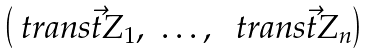<formula> <loc_0><loc_0><loc_500><loc_500>\begin{pmatrix} \ t r a n s { \vec { t } { Z } _ { 1 } } , & \dots , & \ t r a n s { \vec { t } { Z } _ { n } } \end{pmatrix}</formula> 